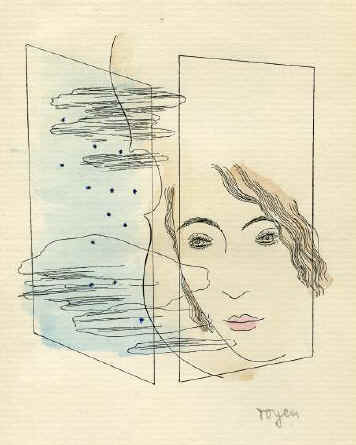Can we interpret any feminist themes in this piece? This artwork could certainly be interpreted through a feminist lens, focusing on the portrayal of the woman. The use of clear, bold lines to define her features against a chaotic background can mirror the societal expectations placed on women to maintain clarity and composure amidst internal or external turmoil. Furthermore, the very act of placing the female form at the center of this surreal, introspective piece could be seen as a statement on the central role of women in navigating complex emotional and psychological terrains. 